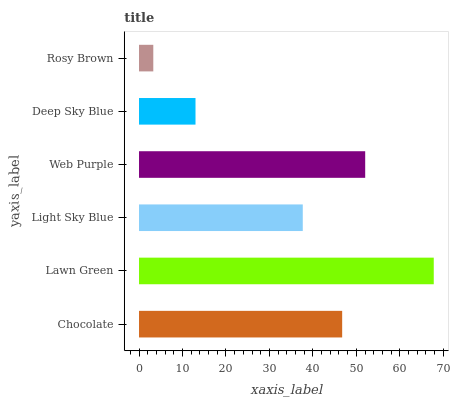Is Rosy Brown the minimum?
Answer yes or no. Yes. Is Lawn Green the maximum?
Answer yes or no. Yes. Is Light Sky Blue the minimum?
Answer yes or no. No. Is Light Sky Blue the maximum?
Answer yes or no. No. Is Lawn Green greater than Light Sky Blue?
Answer yes or no. Yes. Is Light Sky Blue less than Lawn Green?
Answer yes or no. Yes. Is Light Sky Blue greater than Lawn Green?
Answer yes or no. No. Is Lawn Green less than Light Sky Blue?
Answer yes or no. No. Is Chocolate the high median?
Answer yes or no. Yes. Is Light Sky Blue the low median?
Answer yes or no. Yes. Is Light Sky Blue the high median?
Answer yes or no. No. Is Web Purple the low median?
Answer yes or no. No. 